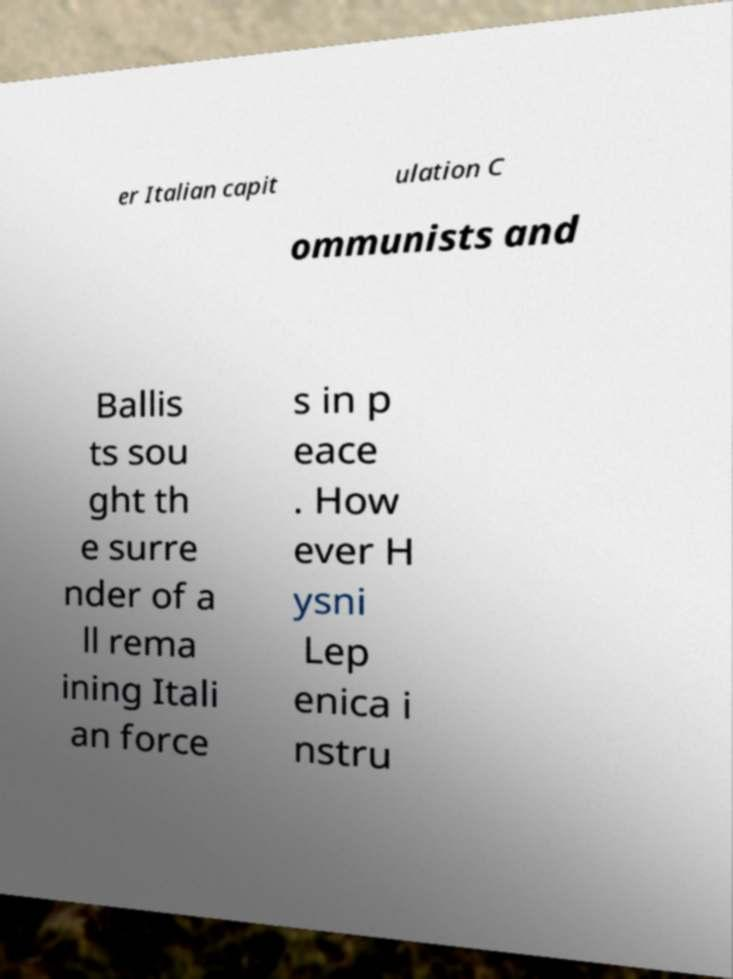Can you read and provide the text displayed in the image?This photo seems to have some interesting text. Can you extract and type it out for me? er Italian capit ulation C ommunists and Ballis ts sou ght th e surre nder of a ll rema ining Itali an force s in p eace . How ever H ysni Lep enica i nstru 